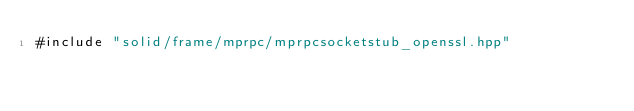Convert code to text. <code><loc_0><loc_0><loc_500><loc_500><_C++_>#include "solid/frame/mprpc/mprpcsocketstub_openssl.hpp"
</code> 